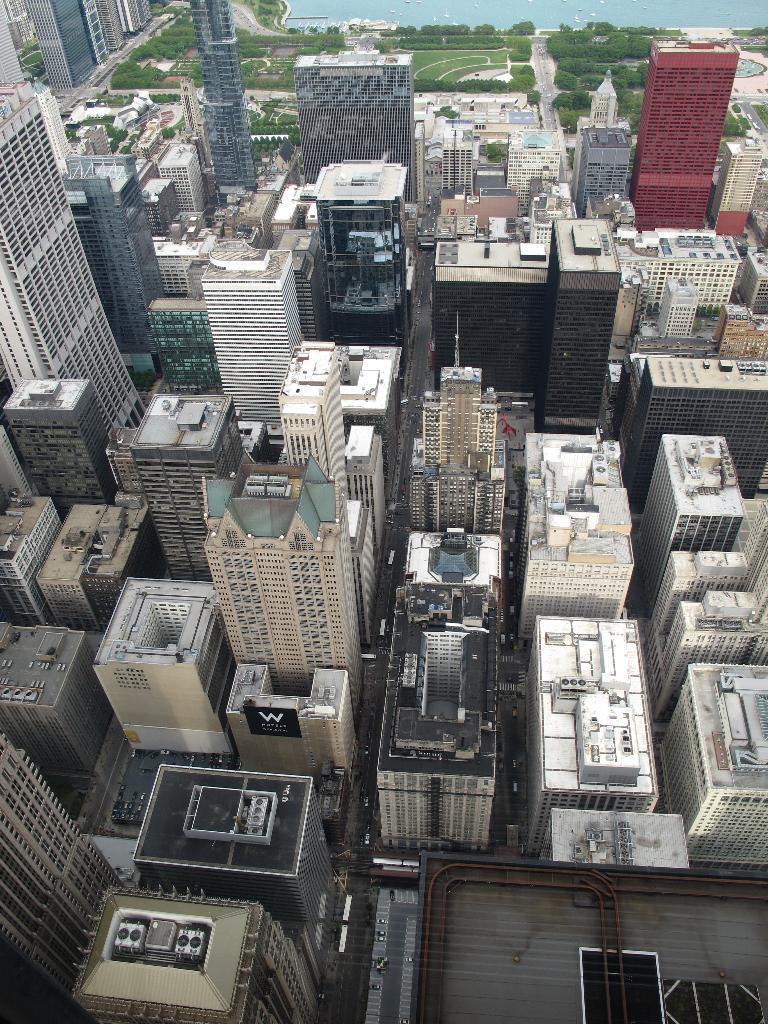What type of structures can be seen in the image? There are buildings visible in the image. What type of vegetation is visible at the top of the image? There are trees visible at the top of the image. What type of war is being fought in the image? There is no war present in the image; it features buildings and trees. How many toes can be seen in the image? There are no toes visible in the image. 